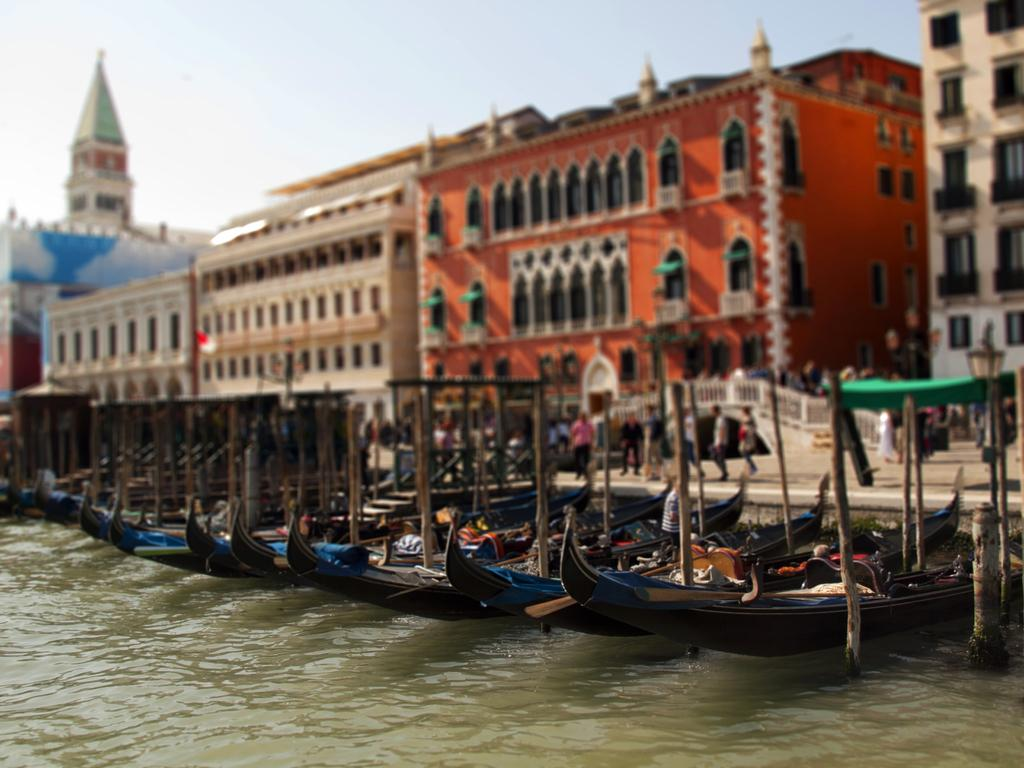What is the main subject of the image? The main subject of the image is boats. Where are the boats located in the image? The boats are on the water in the center of the image. What can be seen in the background of the image? There are buildings, persons, and a tower in the background of the image. How many trees are visible in the image? There are no trees visible in the image; it features boats on the water with buildings, persons, and a tower in the background. 